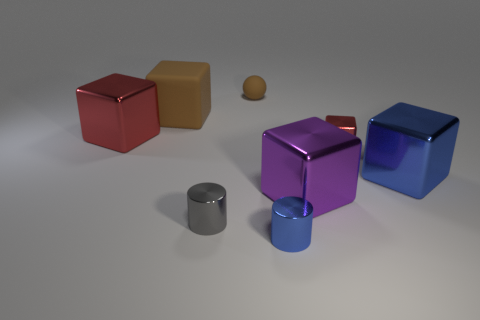The tiny matte thing is what color?
Ensure brevity in your answer.  Brown. Is the color of the big rubber block the same as the small rubber thing?
Your response must be concise. Yes. What number of matte objects are tiny blue cylinders or tiny cylinders?
Provide a succinct answer. 0. There is a small shiny cylinder left of the blue cylinder in front of the small red metal thing; are there any blue things in front of it?
Keep it short and to the point. Yes. There is a gray cylinder that is made of the same material as the large blue thing; what is its size?
Your answer should be compact. Small. Are there any large blocks in front of the big blue object?
Your answer should be compact. Yes. Is there a small blue thing in front of the brown thing that is in front of the tiny matte thing?
Provide a short and direct response. Yes. Does the red shiny cube that is left of the tiny blue cylinder have the same size as the blue metallic block that is in front of the brown cube?
Provide a short and direct response. Yes. How many large objects are rubber blocks or red metallic blocks?
Your response must be concise. 2. There is a block behind the big metal block that is behind the large blue metallic cube; what is its material?
Your answer should be very brief. Rubber. 